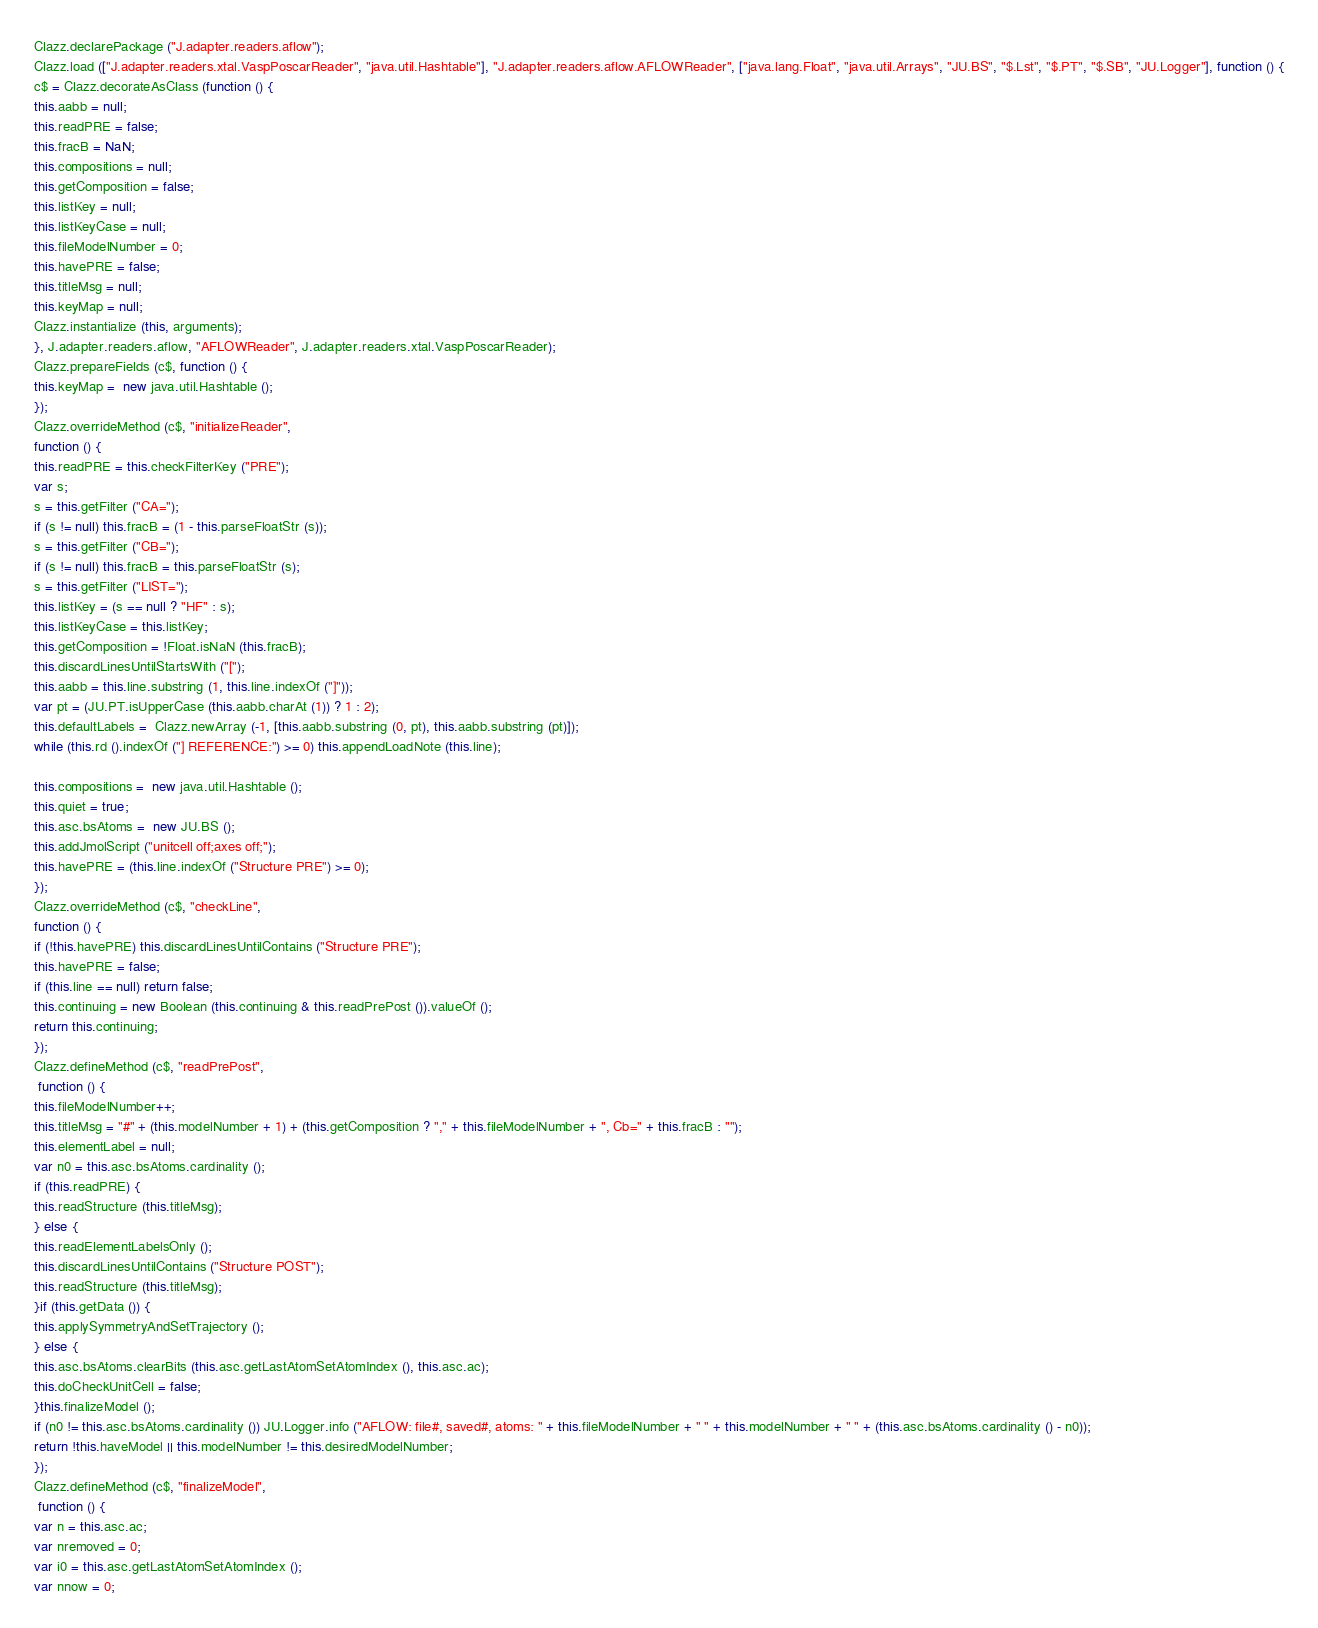<code> <loc_0><loc_0><loc_500><loc_500><_JavaScript_>Clazz.declarePackage ("J.adapter.readers.aflow");
Clazz.load (["J.adapter.readers.xtal.VaspPoscarReader", "java.util.Hashtable"], "J.adapter.readers.aflow.AFLOWReader", ["java.lang.Float", "java.util.Arrays", "JU.BS", "$.Lst", "$.PT", "$.SB", "JU.Logger"], function () {
c$ = Clazz.decorateAsClass (function () {
this.aabb = null;
this.readPRE = false;
this.fracB = NaN;
this.compositions = null;
this.getComposition = false;
this.listKey = null;
this.listKeyCase = null;
this.fileModelNumber = 0;
this.havePRE = false;
this.titleMsg = null;
this.keyMap = null;
Clazz.instantialize (this, arguments);
}, J.adapter.readers.aflow, "AFLOWReader", J.adapter.readers.xtal.VaspPoscarReader);
Clazz.prepareFields (c$, function () {
this.keyMap =  new java.util.Hashtable ();
});
Clazz.overrideMethod (c$, "initializeReader", 
function () {
this.readPRE = this.checkFilterKey ("PRE");
var s;
s = this.getFilter ("CA=");
if (s != null) this.fracB = (1 - this.parseFloatStr (s));
s = this.getFilter ("CB=");
if (s != null) this.fracB = this.parseFloatStr (s);
s = this.getFilter ("LIST=");
this.listKey = (s == null ? "HF" : s);
this.listKeyCase = this.listKey;
this.getComposition = !Float.isNaN (this.fracB);
this.discardLinesUntilStartsWith ("[");
this.aabb = this.line.substring (1, this.line.indexOf ("]"));
var pt = (JU.PT.isUpperCase (this.aabb.charAt (1)) ? 1 : 2);
this.defaultLabels =  Clazz.newArray (-1, [this.aabb.substring (0, pt), this.aabb.substring (pt)]);
while (this.rd ().indexOf ("] REFERENCE:") >= 0) this.appendLoadNote (this.line);

this.compositions =  new java.util.Hashtable ();
this.quiet = true;
this.asc.bsAtoms =  new JU.BS ();
this.addJmolScript ("unitcell off;axes off;");
this.havePRE = (this.line.indexOf ("Structure PRE") >= 0);
});
Clazz.overrideMethod (c$, "checkLine", 
function () {
if (!this.havePRE) this.discardLinesUntilContains ("Structure PRE");
this.havePRE = false;
if (this.line == null) return false;
this.continuing = new Boolean (this.continuing & this.readPrePost ()).valueOf ();
return this.continuing;
});
Clazz.defineMethod (c$, "readPrePost", 
 function () {
this.fileModelNumber++;
this.titleMsg = "#" + (this.modelNumber + 1) + (this.getComposition ? "," + this.fileModelNumber + ", Cb=" + this.fracB : "");
this.elementLabel = null;
var n0 = this.asc.bsAtoms.cardinality ();
if (this.readPRE) {
this.readStructure (this.titleMsg);
} else {
this.readElementLabelsOnly ();
this.discardLinesUntilContains ("Structure POST");
this.readStructure (this.titleMsg);
}if (this.getData ()) {
this.applySymmetryAndSetTrajectory ();
} else {
this.asc.bsAtoms.clearBits (this.asc.getLastAtomSetAtomIndex (), this.asc.ac);
this.doCheckUnitCell = false;
}this.finalizeModel ();
if (n0 != this.asc.bsAtoms.cardinality ()) JU.Logger.info ("AFLOW: file#, saved#, atoms: " + this.fileModelNumber + " " + this.modelNumber + " " + (this.asc.bsAtoms.cardinality () - n0));
return !this.haveModel || this.modelNumber != this.desiredModelNumber;
});
Clazz.defineMethod (c$, "finalizeModel", 
 function () {
var n = this.asc.ac;
var nremoved = 0;
var i0 = this.asc.getLastAtomSetAtomIndex ();
var nnow = 0;</code> 